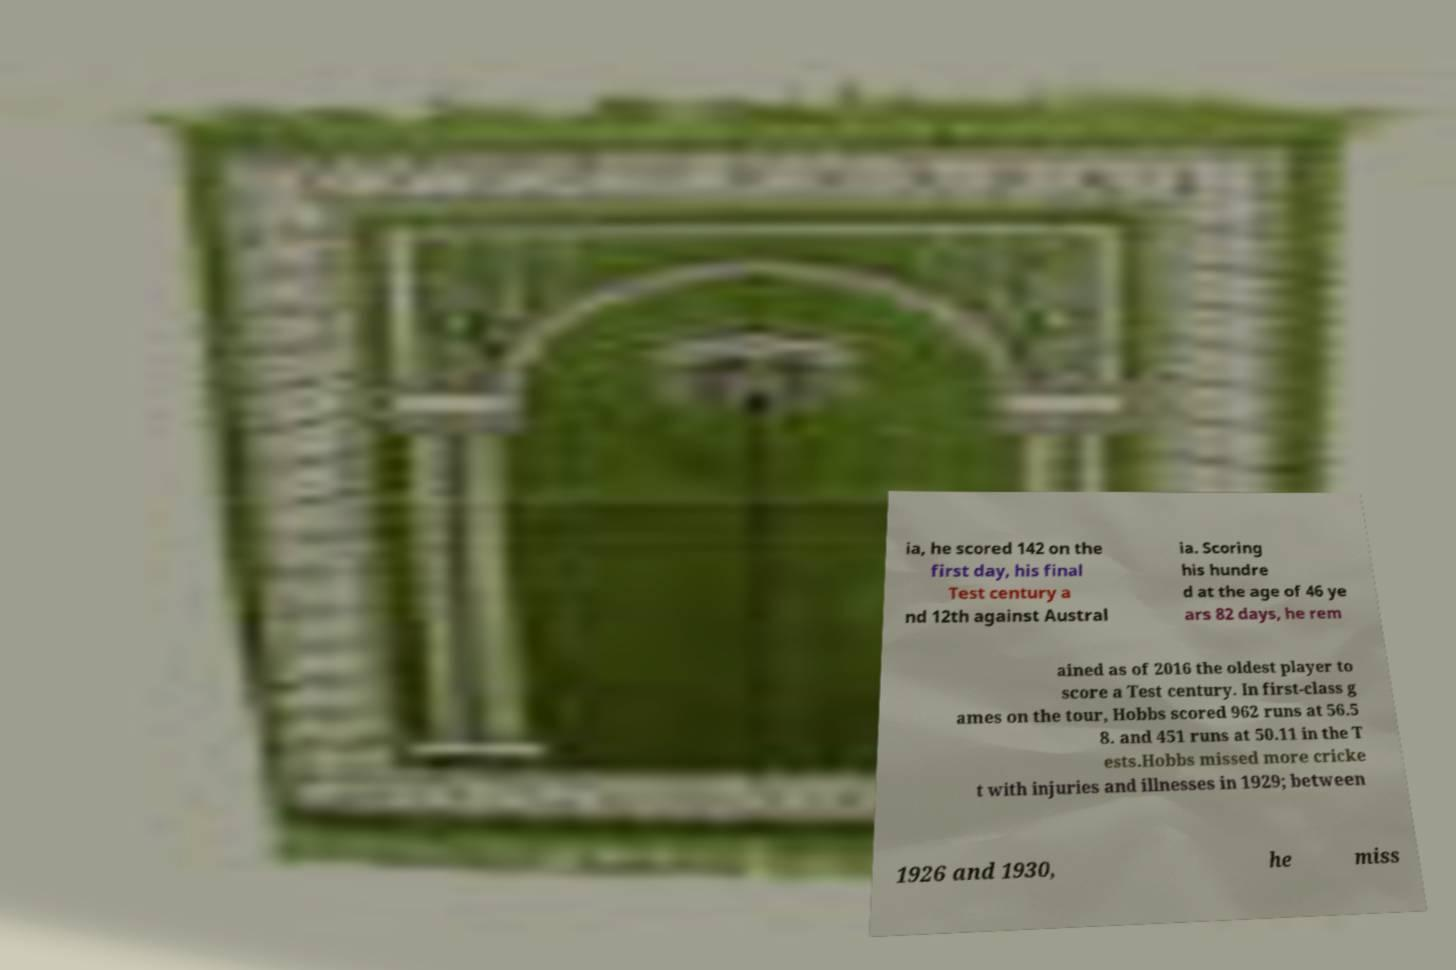I need the written content from this picture converted into text. Can you do that? ia, he scored 142 on the first day, his final Test century a nd 12th against Austral ia. Scoring his hundre d at the age of 46 ye ars 82 days, he rem ained as of 2016 the oldest player to score a Test century. In first-class g ames on the tour, Hobbs scored 962 runs at 56.5 8. and 451 runs at 50.11 in the T ests.Hobbs missed more cricke t with injuries and illnesses in 1929; between 1926 and 1930, he miss 